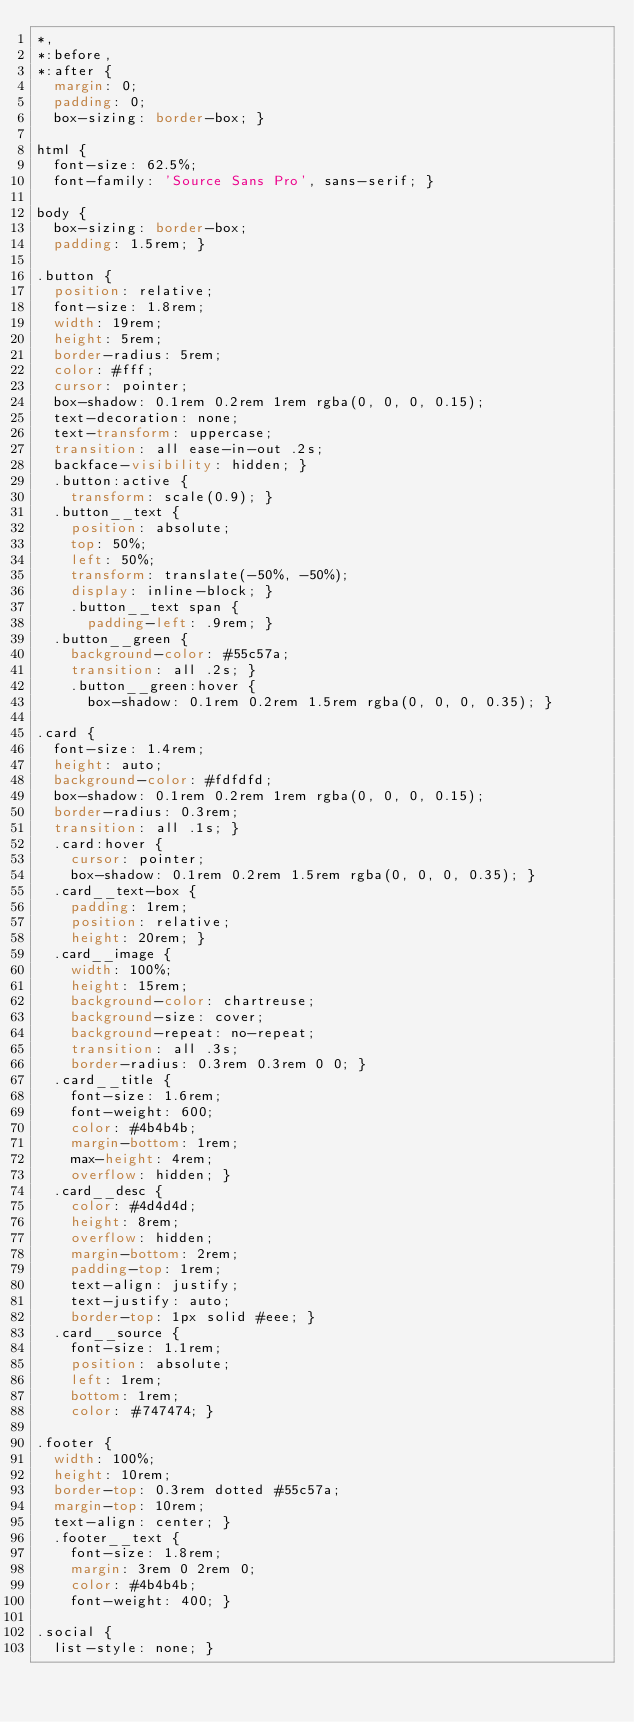Convert code to text. <code><loc_0><loc_0><loc_500><loc_500><_CSS_>*,
*:before,
*:after {
  margin: 0;
  padding: 0;
  box-sizing: border-box; }

html {
  font-size: 62.5%;
  font-family: 'Source Sans Pro', sans-serif; }

body {
  box-sizing: border-box;
  padding: 1.5rem; }

.button {
  position: relative;
  font-size: 1.8rem;
  width: 19rem;
  height: 5rem;
  border-radius: 5rem;
  color: #fff;
  cursor: pointer;
  box-shadow: 0.1rem 0.2rem 1rem rgba(0, 0, 0, 0.15);
  text-decoration: none;
  text-transform: uppercase;
  transition: all ease-in-out .2s;
  backface-visibility: hidden; }
  .button:active {
    transform: scale(0.9); }
  .button__text {
    position: absolute;
    top: 50%;
    left: 50%;
    transform: translate(-50%, -50%);
    display: inline-block; }
    .button__text span {
      padding-left: .9rem; }
  .button__green {
    background-color: #55c57a;
    transition: all .2s; }
    .button__green:hover {
      box-shadow: 0.1rem 0.2rem 1.5rem rgba(0, 0, 0, 0.35); }

.card {
  font-size: 1.4rem;
  height: auto;
  background-color: #fdfdfd;
  box-shadow: 0.1rem 0.2rem 1rem rgba(0, 0, 0, 0.15);
  border-radius: 0.3rem;
  transition: all .1s; }
  .card:hover {
    cursor: pointer;
    box-shadow: 0.1rem 0.2rem 1.5rem rgba(0, 0, 0, 0.35); }
  .card__text-box {
    padding: 1rem;
    position: relative;
    height: 20rem; }
  .card__image {
    width: 100%;
    height: 15rem;
    background-color: chartreuse;
    background-size: cover;
    background-repeat: no-repeat;
    transition: all .3s;
    border-radius: 0.3rem 0.3rem 0 0; }
  .card__title {
    font-size: 1.6rem;
    font-weight: 600;
    color: #4b4b4b;
    margin-bottom: 1rem;
    max-height: 4rem;
    overflow: hidden; }
  .card__desc {
    color: #4d4d4d;
    height: 8rem;
    overflow: hidden;
    margin-bottom: 2rem;
    padding-top: 1rem;
    text-align: justify;
    text-justify: auto;
    border-top: 1px solid #eee; }
  .card__source {
    font-size: 1.1rem;
    position: absolute;
    left: 1rem;
    bottom: 1rem;
    color: #747474; }

.footer {
  width: 100%;
  height: 10rem;
  border-top: 0.3rem dotted #55c57a;
  margin-top: 10rem;
  text-align: center; }
  .footer__text {
    font-size: 1.8rem;
    margin: 3rem 0 2rem 0;
    color: #4b4b4b;
    font-weight: 400; }

.social {
  list-style: none; }</code> 